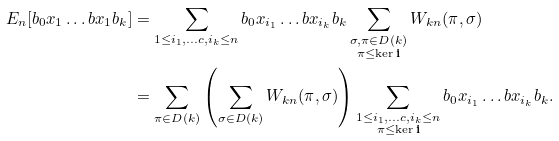<formula> <loc_0><loc_0><loc_500><loc_500>E _ { n } [ b _ { 0 } x _ { 1 } \dots b x _ { 1 } b _ { k } ] & = \sum _ { 1 \leq i _ { 1 } , \dots c , i _ { k } \leq n } b _ { 0 } x _ { i _ { 1 } } \dots b x _ { i _ { k } } b _ { k } \sum _ { \substack { \sigma , \pi \in D ( k ) \\ \pi \leq \ker \mathbf i } } W _ { k n } ( \pi , \sigma ) \\ & = \sum _ { \pi \in D ( k ) } \left ( \sum _ { \sigma \in D ( k ) } W _ { k n } ( \pi , \sigma ) \right ) \sum _ { \substack { 1 \leq i _ { 1 } , \dots c , i _ { k } \leq n \\ \pi \leq \ker \mathbf i } } b _ { 0 } x _ { i _ { 1 } } \dots b x _ { i _ { k } } b _ { k } .</formula> 